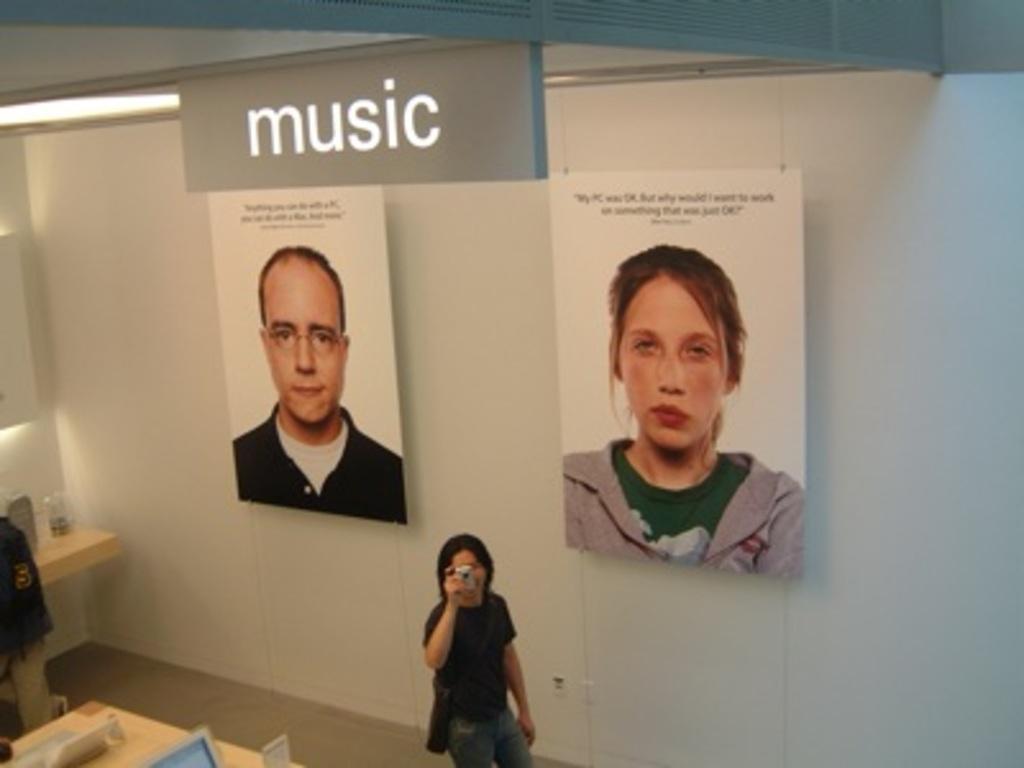Can you describe this image briefly? In this image I can see a person is standing in the front and I can see this person is holding a camera. I can also see this person is wearing black color t shirt and jeans. In the background I can see two posters of two persons and I can also see something is written on the top side of this image. On the bottom left side of this image I can see two tables and on it I can see few stuffs. I can also see a light on the top left side of this image. 